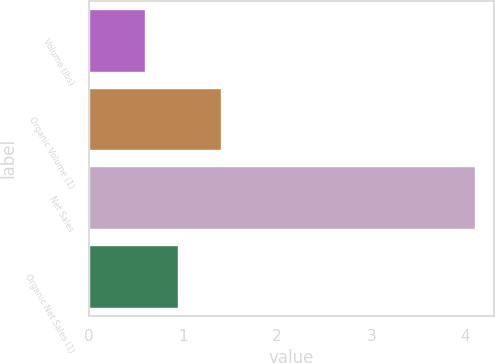Convert chart to OTSL. <chart><loc_0><loc_0><loc_500><loc_500><bar_chart><fcel>Volume (lbs)<fcel>Organic Volume (1)<fcel>Net Sales<fcel>Organic Net Sales (1)<nl><fcel>0.6<fcel>1.4<fcel>4.1<fcel>0.95<nl></chart> 